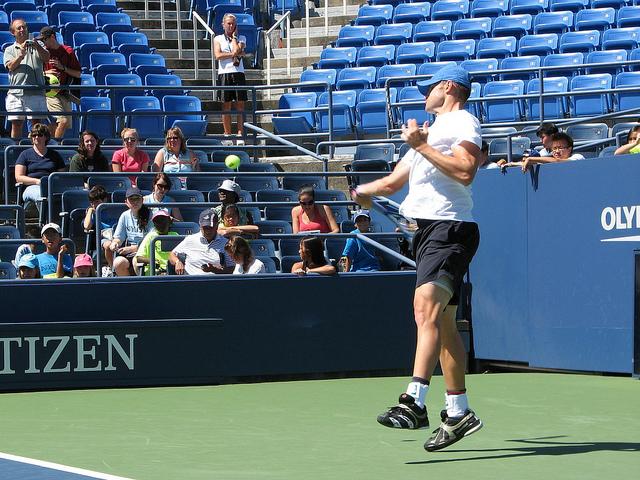How many fans in the stands?
Give a very brief answer. 20. What surface is he on?
Quick response, please. Court. What is the man playing?
Quick response, please. Tennis. Is the audience very engaged in the tennis match?
Give a very brief answer. No. 